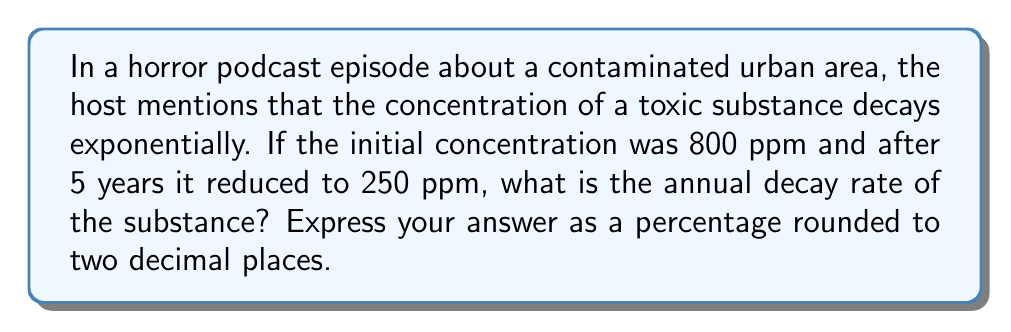Teach me how to tackle this problem. Let's approach this step-by-step:

1) The exponential decay formula is:
   
   $$A(t) = A_0 \cdot e^{-rt}$$

   Where:
   $A(t)$ is the amount at time $t$
   $A_0$ is the initial amount
   $r$ is the decay rate
   $t$ is the time

2) We know:
   $A_0 = 800$ ppm
   $A(5) = 250$ ppm
   $t = 5$ years

3) Let's plug these into our formula:

   $$250 = 800 \cdot e^{-5r}$$

4) Divide both sides by 800:

   $$\frac{250}{800} = e^{-5r}$$

5) Take the natural log of both sides:

   $$\ln(\frac{250}{800}) = -5r$$

6) Solve for $r$:

   $$r = -\frac{1}{5} \ln(\frac{250}{800})$$

7) Calculate:

   $$r = -\frac{1}{5} \ln(0.3125) = 0.2345$$

8) Convert to a percentage:

   $$0.2345 \times 100 = 23.45\%$$

9) Round to two decimal places: 23.45%
Answer: 23.45% 